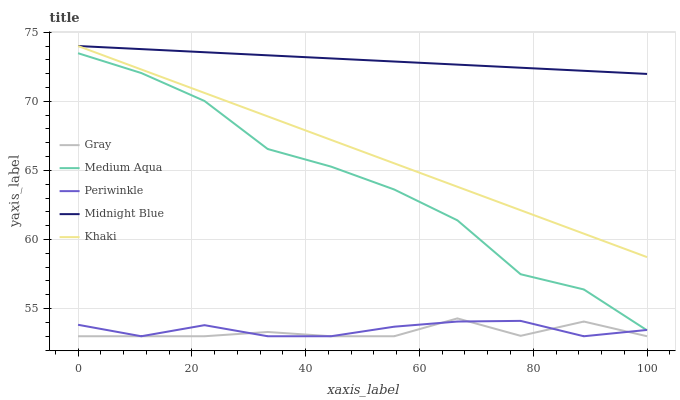Does Periwinkle have the minimum area under the curve?
Answer yes or no. No. Does Periwinkle have the maximum area under the curve?
Answer yes or no. No. Is Periwinkle the smoothest?
Answer yes or no. No. Is Periwinkle the roughest?
Answer yes or no. No. Does Khaki have the lowest value?
Answer yes or no. No. Does Periwinkle have the highest value?
Answer yes or no. No. Is Medium Aqua less than Khaki?
Answer yes or no. Yes. Is Khaki greater than Medium Aqua?
Answer yes or no. Yes. Does Medium Aqua intersect Khaki?
Answer yes or no. No. 